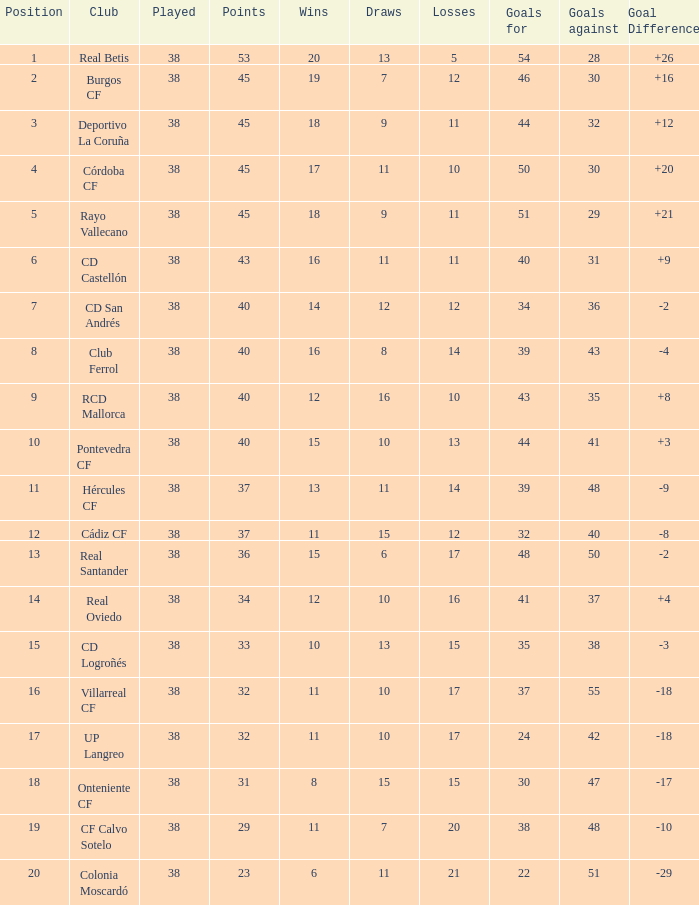What is the highest Goals Against, when Club is "Pontevedra CF", and when Played is less than 38? None. 